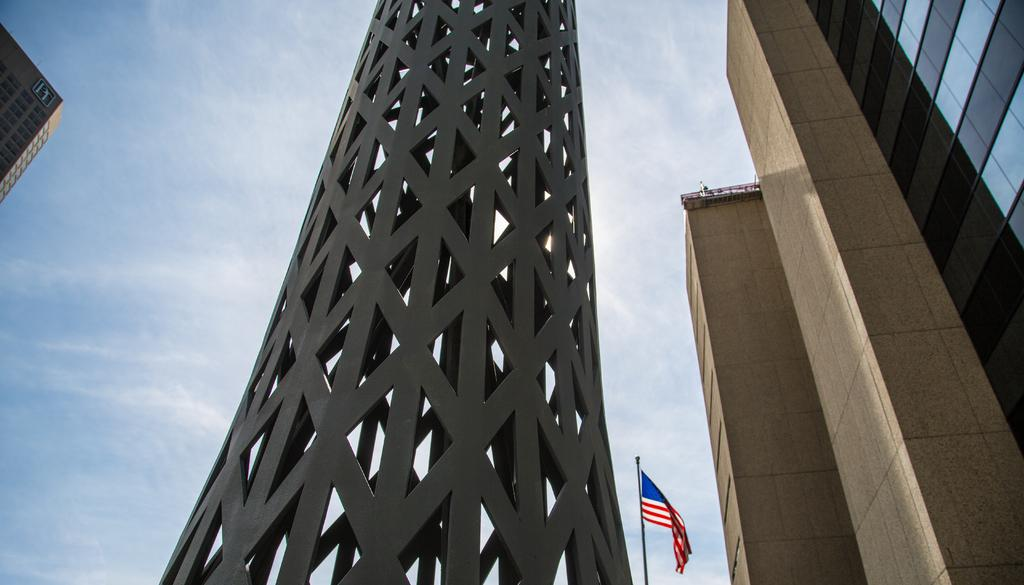What is the main structure in the center of the image? There is a tower in the center of the image. What can be seen on the right side of the image? There are buildings on the right side of the image. Is there any symbol or emblem in the image? Yes, there is a flag in the image. What is located on the left side of the image? There is a building on the left side of the image. How would you describe the weather in the image? The sky is cloudy in the image. Where is the toy located in the image? There is no toy present in the image. Can you see anyone lifting a chair in the image? There is no one lifting a chair in the image. 